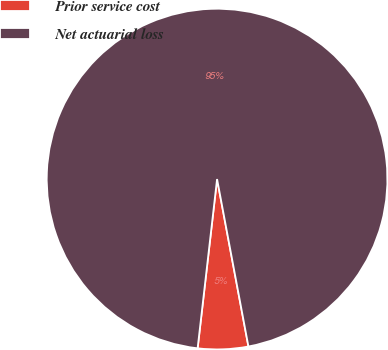<chart> <loc_0><loc_0><loc_500><loc_500><pie_chart><fcel>Prior service cost<fcel>Net actuarial loss<nl><fcel>4.77%<fcel>95.23%<nl></chart> 